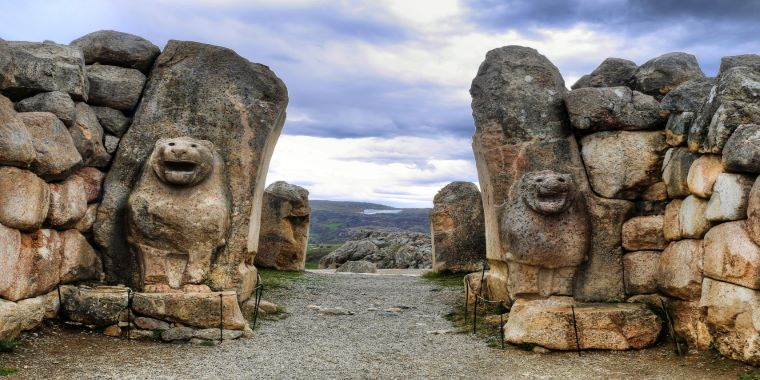How do these architectural elements reflect the broader Hittite civilization? The architectural elements of the Lion Gate reflect the broader Hittite civilization’s importance on defense and religious symbolism. The strategic use of stone, a durable and protective material, in their city gates and walls, indicates the constant threat of invasion and the Hittites’ response to it. Additionally, the religious symbolism of the lions as protectors speaks to the blending of practical and spiritual considerations in their urban planning. This duality showcases the Hittites' sophisticated approach to both city fortification and the embedding of cultural and religious values within public structures. 